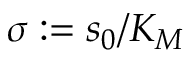<formula> <loc_0><loc_0><loc_500><loc_500>\sigma \colon = s _ { 0 } / K _ { M }</formula> 